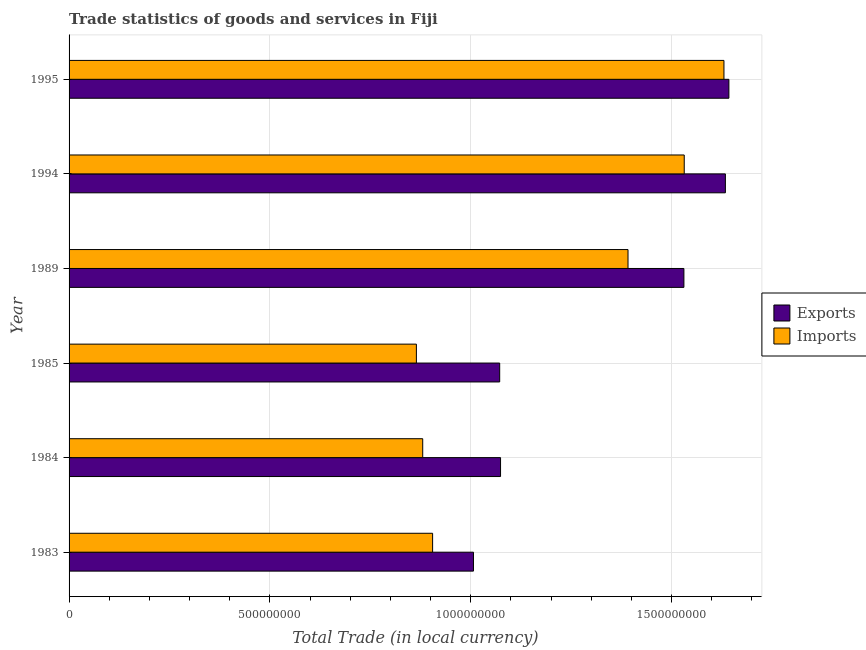How many different coloured bars are there?
Offer a very short reply. 2. Are the number of bars on each tick of the Y-axis equal?
Ensure brevity in your answer.  Yes. In how many cases, is the number of bars for a given year not equal to the number of legend labels?
Offer a very short reply. 0. What is the imports of goods and services in 1995?
Offer a terse response. 1.63e+09. Across all years, what is the maximum imports of goods and services?
Give a very brief answer. 1.63e+09. Across all years, what is the minimum export of goods and services?
Offer a terse response. 1.01e+09. In which year was the imports of goods and services maximum?
Provide a short and direct response. 1995. What is the total export of goods and services in the graph?
Your answer should be compact. 7.96e+09. What is the difference between the export of goods and services in 1984 and that in 1994?
Make the answer very short. -5.60e+08. What is the difference between the imports of goods and services in 1989 and the export of goods and services in 1994?
Give a very brief answer. -2.42e+08. What is the average export of goods and services per year?
Keep it short and to the point. 1.33e+09. In the year 1995, what is the difference between the export of goods and services and imports of goods and services?
Give a very brief answer. 1.23e+07. What is the ratio of the imports of goods and services in 1983 to that in 1995?
Your answer should be very brief. 0.56. What is the difference between the highest and the second highest export of goods and services?
Offer a terse response. 8.73e+06. What is the difference between the highest and the lowest export of goods and services?
Your answer should be very brief. 6.36e+08. In how many years, is the export of goods and services greater than the average export of goods and services taken over all years?
Provide a short and direct response. 3. What does the 1st bar from the top in 1985 represents?
Offer a very short reply. Imports. What does the 1st bar from the bottom in 1989 represents?
Provide a succinct answer. Exports. How many bars are there?
Give a very brief answer. 12. Are the values on the major ticks of X-axis written in scientific E-notation?
Keep it short and to the point. No. How many legend labels are there?
Give a very brief answer. 2. What is the title of the graph?
Ensure brevity in your answer.  Trade statistics of goods and services in Fiji. Does "Age 65(male)" appear as one of the legend labels in the graph?
Provide a succinct answer. No. What is the label or title of the X-axis?
Provide a short and direct response. Total Trade (in local currency). What is the label or title of the Y-axis?
Offer a terse response. Year. What is the Total Trade (in local currency) in Exports in 1983?
Ensure brevity in your answer.  1.01e+09. What is the Total Trade (in local currency) in Imports in 1983?
Keep it short and to the point. 9.05e+08. What is the Total Trade (in local currency) of Exports in 1984?
Give a very brief answer. 1.07e+09. What is the Total Trade (in local currency) in Imports in 1984?
Provide a succinct answer. 8.81e+08. What is the Total Trade (in local currency) in Exports in 1985?
Your response must be concise. 1.07e+09. What is the Total Trade (in local currency) in Imports in 1985?
Your response must be concise. 8.65e+08. What is the Total Trade (in local currency) in Exports in 1989?
Make the answer very short. 1.53e+09. What is the Total Trade (in local currency) of Imports in 1989?
Provide a short and direct response. 1.39e+09. What is the Total Trade (in local currency) in Exports in 1994?
Provide a short and direct response. 1.63e+09. What is the Total Trade (in local currency) in Imports in 1994?
Your answer should be very brief. 1.53e+09. What is the Total Trade (in local currency) of Exports in 1995?
Ensure brevity in your answer.  1.64e+09. What is the Total Trade (in local currency) of Imports in 1995?
Your response must be concise. 1.63e+09. Across all years, what is the maximum Total Trade (in local currency) in Exports?
Offer a terse response. 1.64e+09. Across all years, what is the maximum Total Trade (in local currency) of Imports?
Offer a very short reply. 1.63e+09. Across all years, what is the minimum Total Trade (in local currency) in Exports?
Your answer should be very brief. 1.01e+09. Across all years, what is the minimum Total Trade (in local currency) in Imports?
Provide a succinct answer. 8.65e+08. What is the total Total Trade (in local currency) in Exports in the graph?
Your answer should be compact. 7.96e+09. What is the total Total Trade (in local currency) of Imports in the graph?
Offer a terse response. 7.20e+09. What is the difference between the Total Trade (in local currency) of Exports in 1983 and that in 1984?
Provide a short and direct response. -6.74e+07. What is the difference between the Total Trade (in local currency) of Imports in 1983 and that in 1984?
Provide a succinct answer. 2.47e+07. What is the difference between the Total Trade (in local currency) of Exports in 1983 and that in 1985?
Provide a succinct answer. -6.53e+07. What is the difference between the Total Trade (in local currency) of Imports in 1983 and that in 1985?
Provide a short and direct response. 4.04e+07. What is the difference between the Total Trade (in local currency) of Exports in 1983 and that in 1989?
Offer a terse response. -5.24e+08. What is the difference between the Total Trade (in local currency) of Imports in 1983 and that in 1989?
Ensure brevity in your answer.  -4.87e+08. What is the difference between the Total Trade (in local currency) of Exports in 1983 and that in 1994?
Your answer should be very brief. -6.27e+08. What is the difference between the Total Trade (in local currency) of Imports in 1983 and that in 1994?
Ensure brevity in your answer.  -6.27e+08. What is the difference between the Total Trade (in local currency) in Exports in 1983 and that in 1995?
Offer a very short reply. -6.36e+08. What is the difference between the Total Trade (in local currency) of Imports in 1983 and that in 1995?
Make the answer very short. -7.25e+08. What is the difference between the Total Trade (in local currency) of Exports in 1984 and that in 1985?
Make the answer very short. 2.13e+06. What is the difference between the Total Trade (in local currency) of Imports in 1984 and that in 1985?
Offer a very short reply. 1.58e+07. What is the difference between the Total Trade (in local currency) of Exports in 1984 and that in 1989?
Provide a succinct answer. -4.57e+08. What is the difference between the Total Trade (in local currency) in Imports in 1984 and that in 1989?
Keep it short and to the point. -5.11e+08. What is the difference between the Total Trade (in local currency) of Exports in 1984 and that in 1994?
Your answer should be compact. -5.60e+08. What is the difference between the Total Trade (in local currency) of Imports in 1984 and that in 1994?
Offer a terse response. -6.51e+08. What is the difference between the Total Trade (in local currency) of Exports in 1984 and that in 1995?
Make the answer very short. -5.69e+08. What is the difference between the Total Trade (in local currency) of Imports in 1984 and that in 1995?
Offer a terse response. -7.50e+08. What is the difference between the Total Trade (in local currency) of Exports in 1985 and that in 1989?
Provide a succinct answer. -4.59e+08. What is the difference between the Total Trade (in local currency) of Imports in 1985 and that in 1989?
Make the answer very short. -5.27e+08. What is the difference between the Total Trade (in local currency) of Exports in 1985 and that in 1994?
Keep it short and to the point. -5.62e+08. What is the difference between the Total Trade (in local currency) in Imports in 1985 and that in 1994?
Make the answer very short. -6.67e+08. What is the difference between the Total Trade (in local currency) of Exports in 1985 and that in 1995?
Provide a succinct answer. -5.71e+08. What is the difference between the Total Trade (in local currency) in Imports in 1985 and that in 1995?
Your answer should be compact. -7.66e+08. What is the difference between the Total Trade (in local currency) in Exports in 1989 and that in 1994?
Provide a succinct answer. -1.03e+08. What is the difference between the Total Trade (in local currency) in Imports in 1989 and that in 1994?
Your response must be concise. -1.40e+08. What is the difference between the Total Trade (in local currency) of Exports in 1989 and that in 1995?
Offer a terse response. -1.12e+08. What is the difference between the Total Trade (in local currency) in Imports in 1989 and that in 1995?
Make the answer very short. -2.39e+08. What is the difference between the Total Trade (in local currency) in Exports in 1994 and that in 1995?
Offer a terse response. -8.73e+06. What is the difference between the Total Trade (in local currency) in Imports in 1994 and that in 1995?
Your answer should be compact. -9.89e+07. What is the difference between the Total Trade (in local currency) in Exports in 1983 and the Total Trade (in local currency) in Imports in 1984?
Offer a terse response. 1.26e+08. What is the difference between the Total Trade (in local currency) of Exports in 1983 and the Total Trade (in local currency) of Imports in 1985?
Your response must be concise. 1.42e+08. What is the difference between the Total Trade (in local currency) of Exports in 1983 and the Total Trade (in local currency) of Imports in 1989?
Your answer should be compact. -3.85e+08. What is the difference between the Total Trade (in local currency) of Exports in 1983 and the Total Trade (in local currency) of Imports in 1994?
Keep it short and to the point. -5.25e+08. What is the difference between the Total Trade (in local currency) in Exports in 1983 and the Total Trade (in local currency) in Imports in 1995?
Provide a short and direct response. -6.24e+08. What is the difference between the Total Trade (in local currency) in Exports in 1984 and the Total Trade (in local currency) in Imports in 1985?
Offer a terse response. 2.10e+08. What is the difference between the Total Trade (in local currency) in Exports in 1984 and the Total Trade (in local currency) in Imports in 1989?
Your answer should be very brief. -3.17e+08. What is the difference between the Total Trade (in local currency) in Exports in 1984 and the Total Trade (in local currency) in Imports in 1994?
Make the answer very short. -4.57e+08. What is the difference between the Total Trade (in local currency) of Exports in 1984 and the Total Trade (in local currency) of Imports in 1995?
Offer a terse response. -5.56e+08. What is the difference between the Total Trade (in local currency) of Exports in 1985 and the Total Trade (in local currency) of Imports in 1989?
Your answer should be compact. -3.19e+08. What is the difference between the Total Trade (in local currency) in Exports in 1985 and the Total Trade (in local currency) in Imports in 1994?
Offer a terse response. -4.60e+08. What is the difference between the Total Trade (in local currency) in Exports in 1985 and the Total Trade (in local currency) in Imports in 1995?
Keep it short and to the point. -5.58e+08. What is the difference between the Total Trade (in local currency) in Exports in 1989 and the Total Trade (in local currency) in Imports in 1994?
Give a very brief answer. -8.19e+05. What is the difference between the Total Trade (in local currency) in Exports in 1989 and the Total Trade (in local currency) in Imports in 1995?
Give a very brief answer. -9.97e+07. What is the difference between the Total Trade (in local currency) in Exports in 1994 and the Total Trade (in local currency) in Imports in 1995?
Your answer should be very brief. 3.57e+06. What is the average Total Trade (in local currency) of Exports per year?
Keep it short and to the point. 1.33e+09. What is the average Total Trade (in local currency) in Imports per year?
Make the answer very short. 1.20e+09. In the year 1983, what is the difference between the Total Trade (in local currency) of Exports and Total Trade (in local currency) of Imports?
Your answer should be very brief. 1.02e+08. In the year 1984, what is the difference between the Total Trade (in local currency) of Exports and Total Trade (in local currency) of Imports?
Your answer should be very brief. 1.94e+08. In the year 1985, what is the difference between the Total Trade (in local currency) of Exports and Total Trade (in local currency) of Imports?
Make the answer very short. 2.07e+08. In the year 1989, what is the difference between the Total Trade (in local currency) in Exports and Total Trade (in local currency) in Imports?
Provide a short and direct response. 1.39e+08. In the year 1994, what is the difference between the Total Trade (in local currency) in Exports and Total Trade (in local currency) in Imports?
Provide a short and direct response. 1.02e+08. In the year 1995, what is the difference between the Total Trade (in local currency) in Exports and Total Trade (in local currency) in Imports?
Your answer should be very brief. 1.23e+07. What is the ratio of the Total Trade (in local currency) in Exports in 1983 to that in 1984?
Provide a succinct answer. 0.94. What is the ratio of the Total Trade (in local currency) of Imports in 1983 to that in 1984?
Keep it short and to the point. 1.03. What is the ratio of the Total Trade (in local currency) of Exports in 1983 to that in 1985?
Give a very brief answer. 0.94. What is the ratio of the Total Trade (in local currency) in Imports in 1983 to that in 1985?
Provide a short and direct response. 1.05. What is the ratio of the Total Trade (in local currency) in Exports in 1983 to that in 1989?
Keep it short and to the point. 0.66. What is the ratio of the Total Trade (in local currency) in Imports in 1983 to that in 1989?
Give a very brief answer. 0.65. What is the ratio of the Total Trade (in local currency) in Exports in 1983 to that in 1994?
Your answer should be compact. 0.62. What is the ratio of the Total Trade (in local currency) of Imports in 1983 to that in 1994?
Offer a very short reply. 0.59. What is the ratio of the Total Trade (in local currency) in Exports in 1983 to that in 1995?
Ensure brevity in your answer.  0.61. What is the ratio of the Total Trade (in local currency) of Imports in 1983 to that in 1995?
Provide a succinct answer. 0.56. What is the ratio of the Total Trade (in local currency) of Exports in 1984 to that in 1985?
Your answer should be compact. 1. What is the ratio of the Total Trade (in local currency) in Imports in 1984 to that in 1985?
Offer a very short reply. 1.02. What is the ratio of the Total Trade (in local currency) in Exports in 1984 to that in 1989?
Your answer should be compact. 0.7. What is the ratio of the Total Trade (in local currency) in Imports in 1984 to that in 1989?
Provide a short and direct response. 0.63. What is the ratio of the Total Trade (in local currency) in Exports in 1984 to that in 1994?
Your answer should be very brief. 0.66. What is the ratio of the Total Trade (in local currency) in Imports in 1984 to that in 1994?
Provide a short and direct response. 0.57. What is the ratio of the Total Trade (in local currency) in Exports in 1984 to that in 1995?
Your answer should be very brief. 0.65. What is the ratio of the Total Trade (in local currency) of Imports in 1984 to that in 1995?
Your answer should be compact. 0.54. What is the ratio of the Total Trade (in local currency) of Exports in 1985 to that in 1989?
Ensure brevity in your answer.  0.7. What is the ratio of the Total Trade (in local currency) of Imports in 1985 to that in 1989?
Provide a short and direct response. 0.62. What is the ratio of the Total Trade (in local currency) in Exports in 1985 to that in 1994?
Provide a short and direct response. 0.66. What is the ratio of the Total Trade (in local currency) of Imports in 1985 to that in 1994?
Provide a short and direct response. 0.56. What is the ratio of the Total Trade (in local currency) in Exports in 1985 to that in 1995?
Provide a short and direct response. 0.65. What is the ratio of the Total Trade (in local currency) in Imports in 1985 to that in 1995?
Provide a succinct answer. 0.53. What is the ratio of the Total Trade (in local currency) of Exports in 1989 to that in 1994?
Make the answer very short. 0.94. What is the ratio of the Total Trade (in local currency) of Imports in 1989 to that in 1994?
Provide a succinct answer. 0.91. What is the ratio of the Total Trade (in local currency) of Exports in 1989 to that in 1995?
Make the answer very short. 0.93. What is the ratio of the Total Trade (in local currency) of Imports in 1989 to that in 1995?
Your answer should be very brief. 0.85. What is the ratio of the Total Trade (in local currency) in Imports in 1994 to that in 1995?
Ensure brevity in your answer.  0.94. What is the difference between the highest and the second highest Total Trade (in local currency) in Exports?
Ensure brevity in your answer.  8.73e+06. What is the difference between the highest and the second highest Total Trade (in local currency) in Imports?
Ensure brevity in your answer.  9.89e+07. What is the difference between the highest and the lowest Total Trade (in local currency) of Exports?
Give a very brief answer. 6.36e+08. What is the difference between the highest and the lowest Total Trade (in local currency) of Imports?
Your answer should be compact. 7.66e+08. 